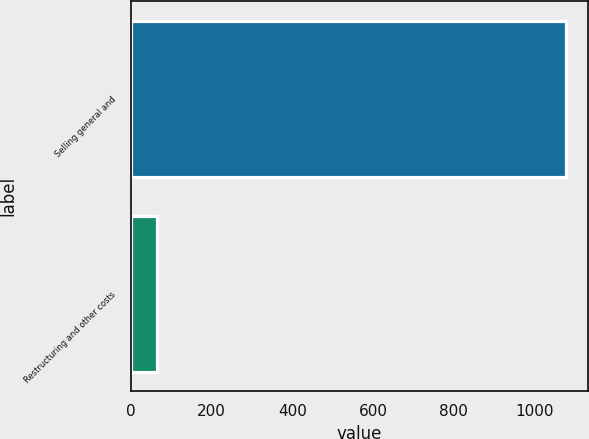<chart> <loc_0><loc_0><loc_500><loc_500><bar_chart><fcel>Selling general and<fcel>Restructuring and other costs<nl><fcel>1077.3<fcel>64.7<nl></chart> 